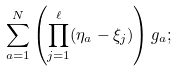Convert formula to latex. <formula><loc_0><loc_0><loc_500><loc_500>\sum _ { a = 1 } ^ { N } \left ( \prod _ { j = 1 } ^ { \ell } ( \eta _ { a } - \xi _ { j } ) \right ) g _ { a } ;</formula> 